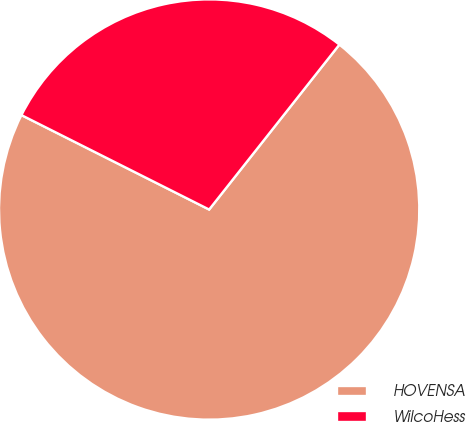<chart> <loc_0><loc_0><loc_500><loc_500><pie_chart><fcel>HOVENSA<fcel>WilcoHess<nl><fcel>71.78%<fcel>28.22%<nl></chart> 